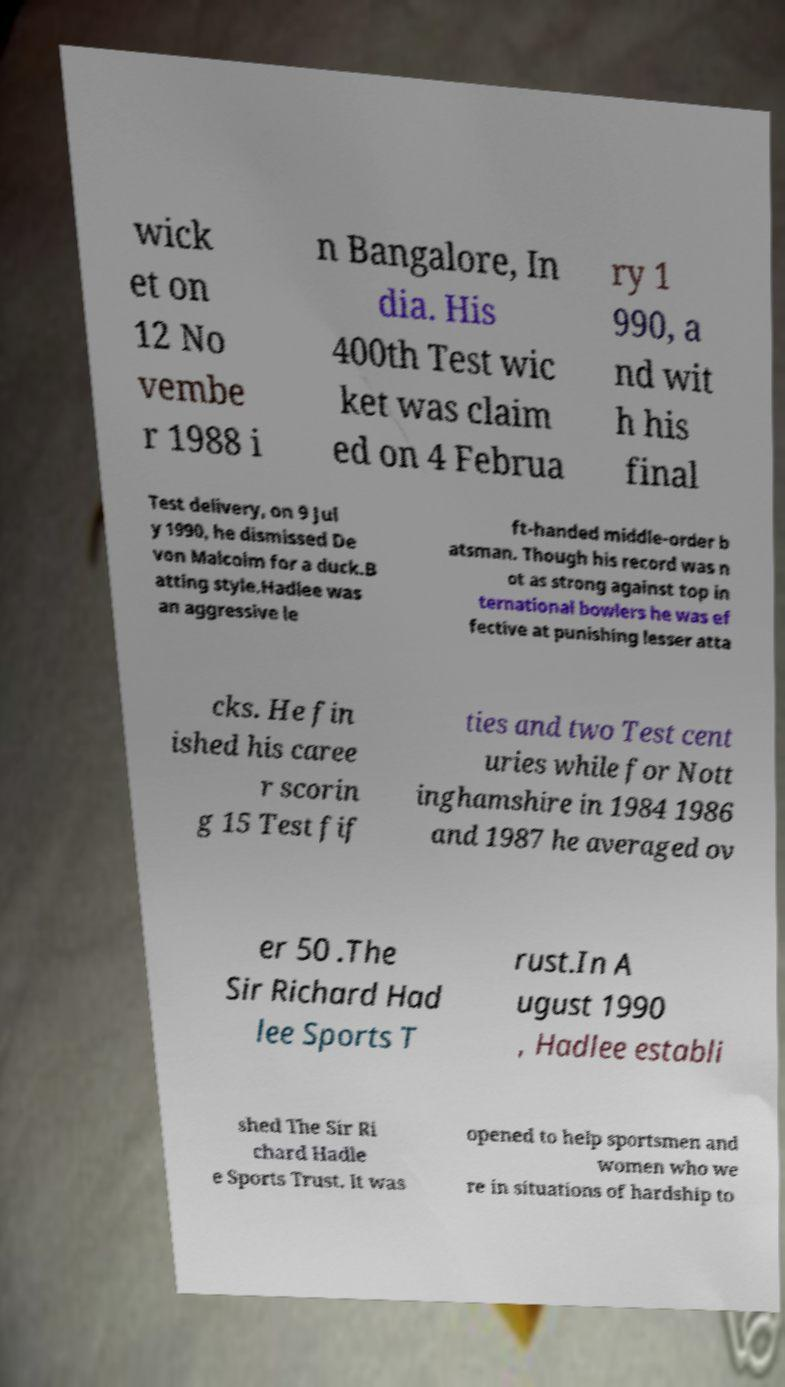There's text embedded in this image that I need extracted. Can you transcribe it verbatim? wick et on 12 No vembe r 1988 i n Bangalore, In dia. His 400th Test wic ket was claim ed on 4 Februa ry 1 990, a nd wit h his final Test delivery, on 9 Jul y 1990, he dismissed De von Malcolm for a duck.B atting style.Hadlee was an aggressive le ft-handed middle-order b atsman. Though his record was n ot as strong against top in ternational bowlers he was ef fective at punishing lesser atta cks. He fin ished his caree r scorin g 15 Test fif ties and two Test cent uries while for Nott inghamshire in 1984 1986 and 1987 he averaged ov er 50 .The Sir Richard Had lee Sports T rust.In A ugust 1990 , Hadlee establi shed The Sir Ri chard Hadle e Sports Trust. It was opened to help sportsmen and women who we re in situations of hardship to 